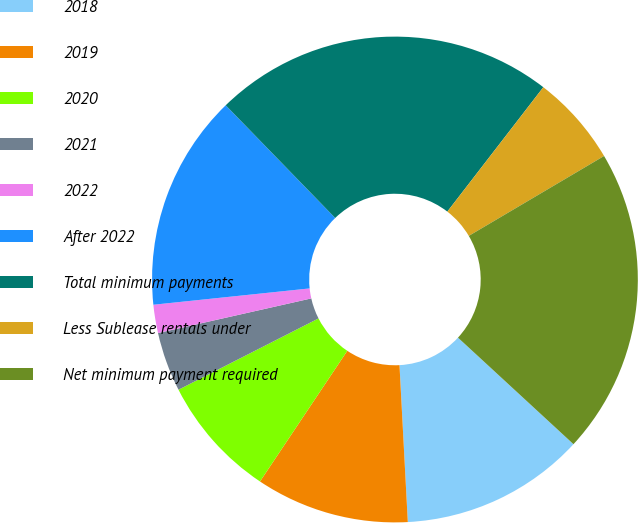<chart> <loc_0><loc_0><loc_500><loc_500><pie_chart><fcel>2018<fcel>2019<fcel>2020<fcel>2021<fcel>2022<fcel>After 2022<fcel>Total minimum payments<fcel>Less Sublease rentals under<fcel>Net minimum payment required<nl><fcel>12.3%<fcel>10.22%<fcel>8.13%<fcel>3.96%<fcel>1.88%<fcel>14.39%<fcel>22.73%<fcel>6.05%<fcel>20.35%<nl></chart> 